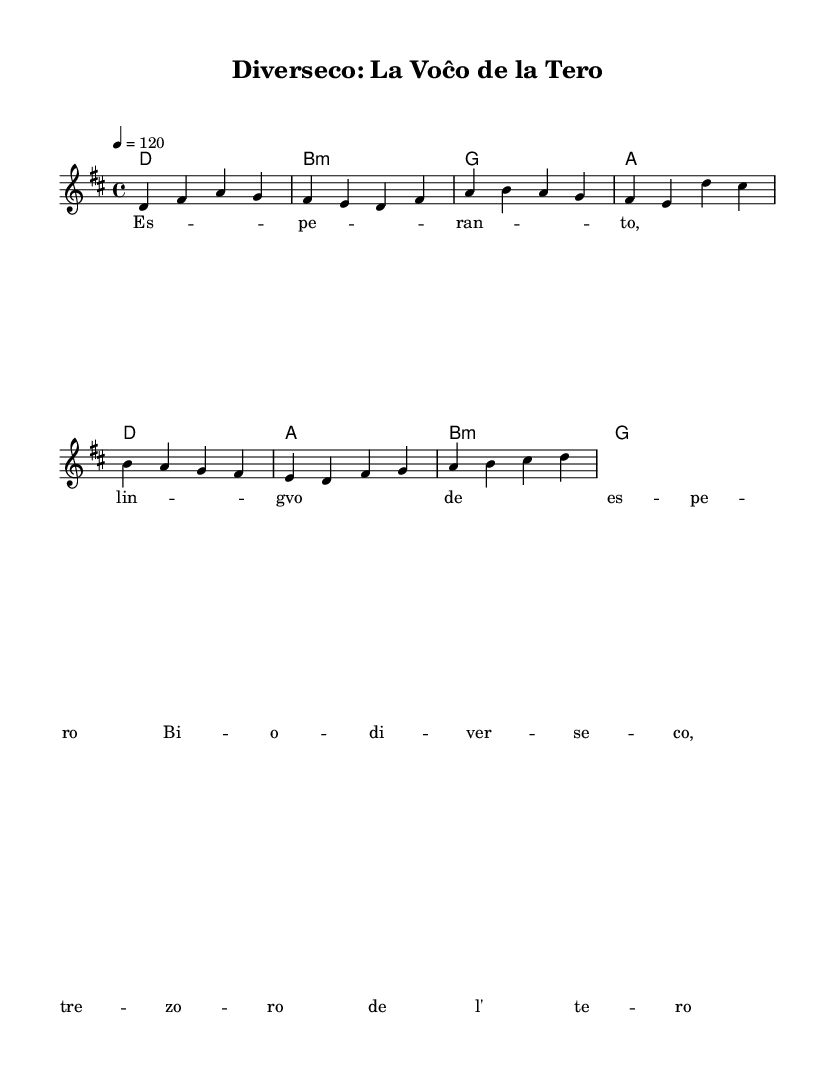what is the key signature of this music? The key signature is indicated at the beginning of the staff, showing two sharps (#), which corresponds to D major.
Answer: D major what is the time signature of this music? The time signature is indicated next to the clef at the beginning of the piece and is shown as 4/4, meaning there are four beats per measure.
Answer: 4/4 what is the tempo marking in this music? The tempo is noted as "4 = 120", which indicates that there are 120 beats per minute.
Answer: 120 how many measures are in the verse? The verse consists of one complete section with a total of 8 measures, as indicated by the grouping of notes and the separation between sections.
Answer: 8 what are the chords used in the chorus? The chorus chords are designated in the chord section which lists D, A, B minor, and G.
Answer: D, A, B minor, G what is the primary theme expressed in the lyrics? The lyrics express themes of language (Esperanto) and biodiversity, as indicated by the phrases about "diverseco" and the "voĉo de la tero".
Answer: Esperanto and biodiversity how does the structure of this music reflect typical rock compositions? The structure follows a common rock pattern of verses and choruses with distinct sections, often characterized by repeated rhythm and chord progressions, which is evident in the arrangement of chords and lyrics throughout the piece.
Answer: Verses and choruses 